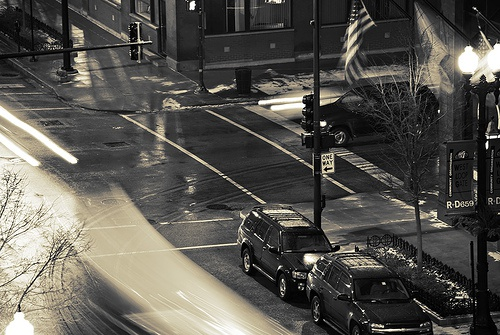Describe the objects in this image and their specific colors. I can see car in gray, black, darkgray, and beige tones, car in gray, black, darkgray, and ivory tones, car in gray, black, ivory, and darkgray tones, traffic light in gray, black, darkgray, and white tones, and traffic light in gray, black, darkgray, and beige tones in this image. 